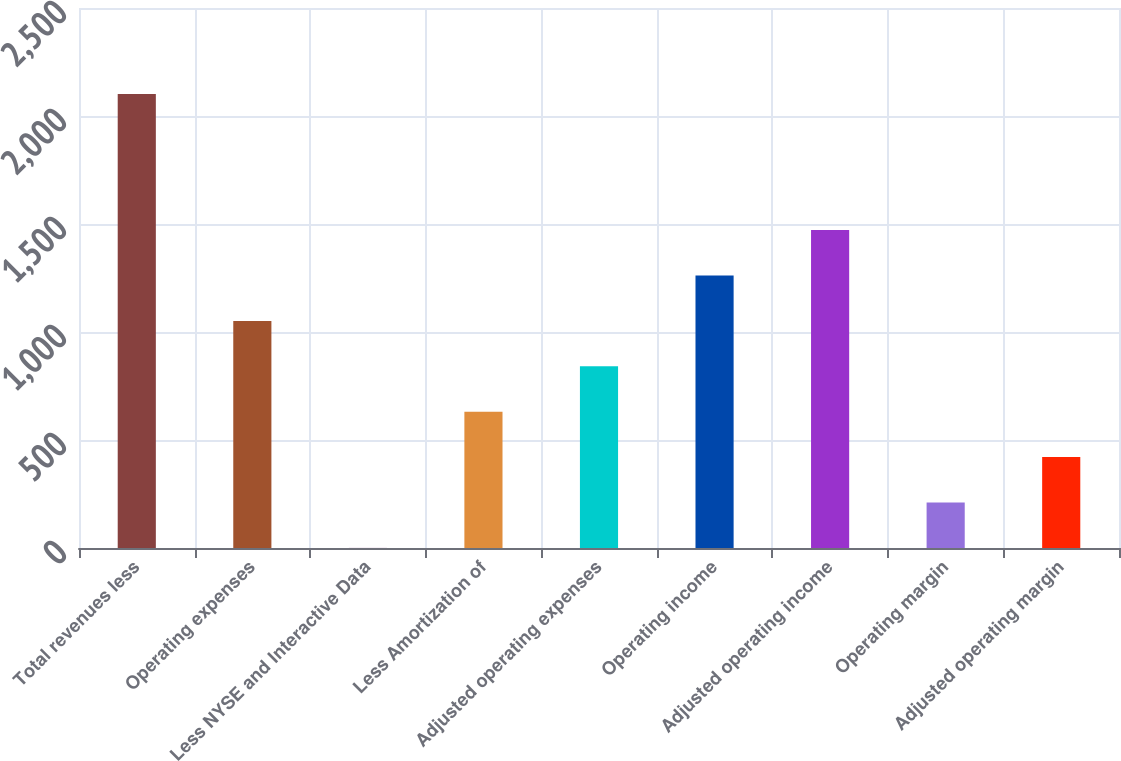Convert chart. <chart><loc_0><loc_0><loc_500><loc_500><bar_chart><fcel>Total revenues less<fcel>Operating expenses<fcel>Less NYSE and Interactive Data<fcel>Less Amortization of<fcel>Adjusted operating expenses<fcel>Operating income<fcel>Adjusted operating income<fcel>Operating margin<fcel>Adjusted operating margin<nl><fcel>2102<fcel>1051.5<fcel>1<fcel>631.3<fcel>841.4<fcel>1261.6<fcel>1471.7<fcel>211.1<fcel>421.2<nl></chart> 